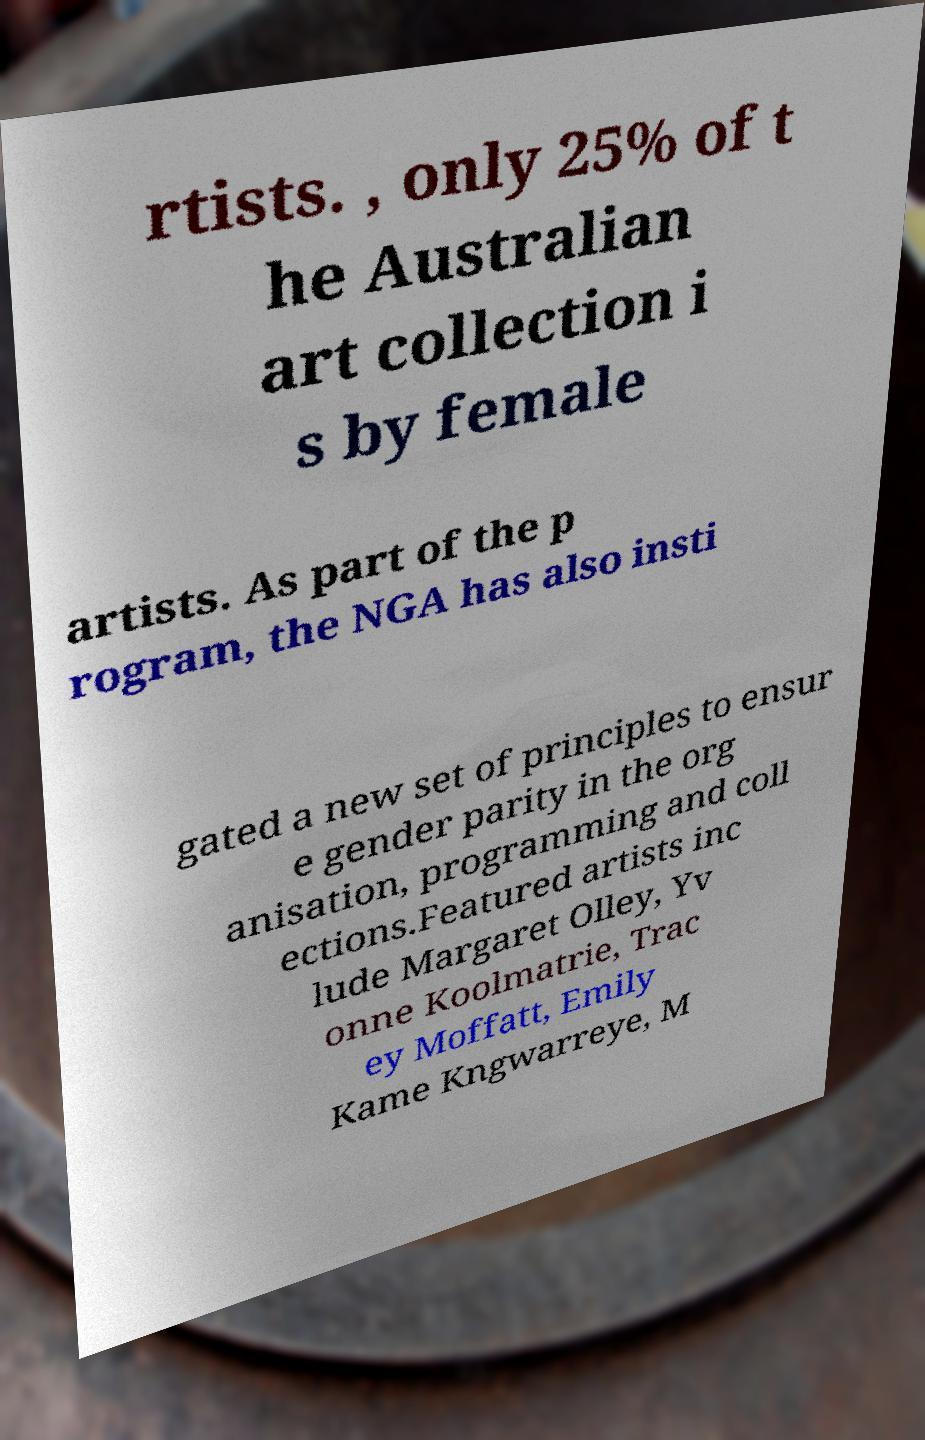There's text embedded in this image that I need extracted. Can you transcribe it verbatim? rtists. , only 25% of t he Australian art collection i s by female artists. As part of the p rogram, the NGA has also insti gated a new set of principles to ensur e gender parity in the org anisation, programming and coll ections.Featured artists inc lude Margaret Olley, Yv onne Koolmatrie, Trac ey Moffatt, Emily Kame Kngwarreye, M 